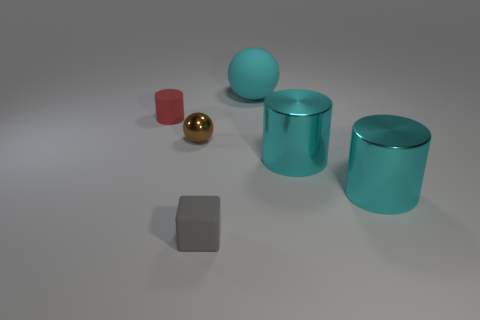How big is the rubber object in front of the cylinder on the left side of the big cyan rubber object?
Give a very brief answer. Small. There is a cyan thing that is the same shape as the brown thing; what is it made of?
Your response must be concise. Rubber. What number of big cyan shiny cylinders are there?
Your answer should be very brief. 2. There is a tiny matte object on the left side of the matte thing that is in front of the shiny thing that is to the left of the large cyan ball; what color is it?
Provide a succinct answer. Red. Is the number of large metal cylinders less than the number of matte objects?
Provide a short and direct response. Yes. There is another matte object that is the same shape as the tiny brown object; what is its color?
Make the answer very short. Cyan. What color is the cylinder that is made of the same material as the tiny gray block?
Offer a very short reply. Red. What number of cylinders have the same size as the block?
Provide a succinct answer. 1. What is the material of the tiny gray object?
Keep it short and to the point. Rubber. Are there more red cylinders than cyan metal blocks?
Keep it short and to the point. Yes. 